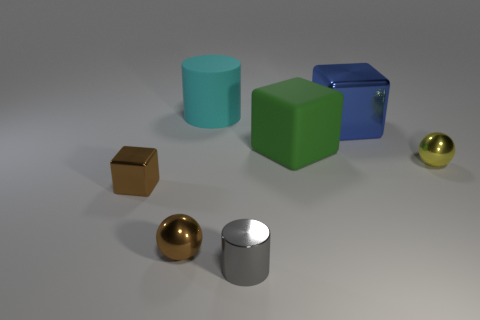Add 2 tiny purple blocks. How many objects exist? 9 Subtract all green rubber blocks. How many blocks are left? 2 Subtract 1 blocks. How many blocks are left? 2 Subtract all cylinders. How many objects are left? 5 Subtract all brown cubes. How many cubes are left? 2 Subtract all green cylinders. How many brown spheres are left? 1 Subtract all brown shiny objects. Subtract all big blue metal blocks. How many objects are left? 4 Add 3 blue shiny objects. How many blue shiny objects are left? 4 Add 7 blocks. How many blocks exist? 10 Subtract 1 cyan cylinders. How many objects are left? 6 